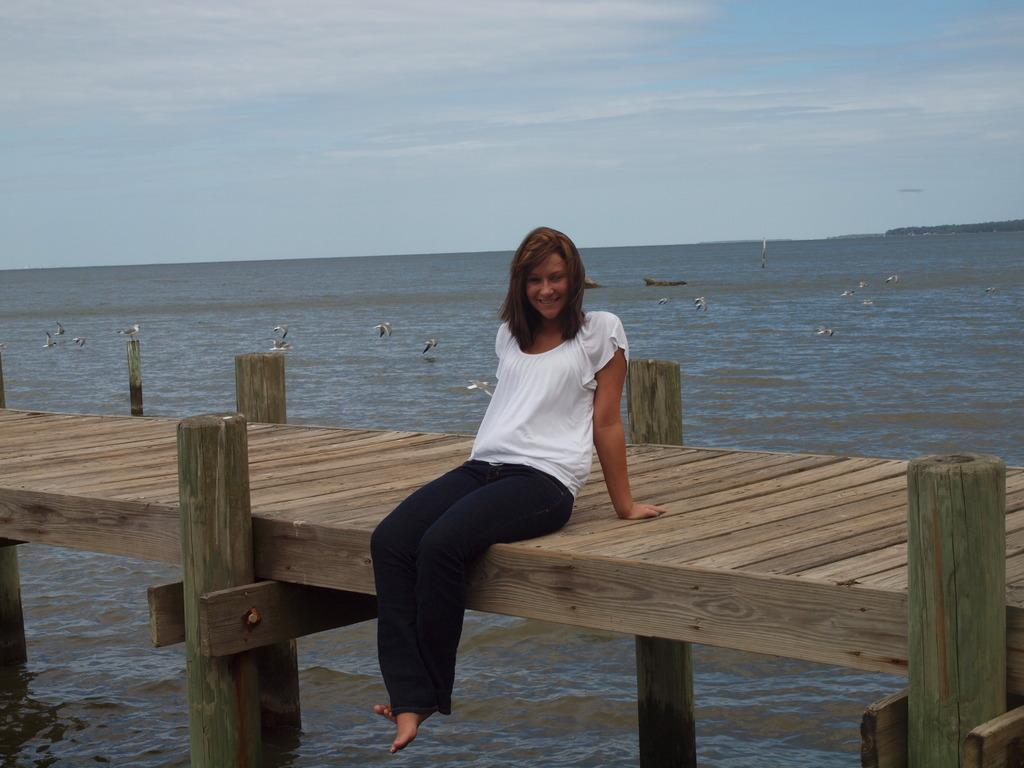What is the lady doing in the image? The lady is sitting on a wooden path in the image. What can be seen in the background of the image? Fishes are leaping out of the sea in the background. What part of the natural environment is visible in the image? The sky is visible in the image. How much credit does the lady have in the image? There is no mention of credit or financial transactions in the image, so it cannot be determined. 